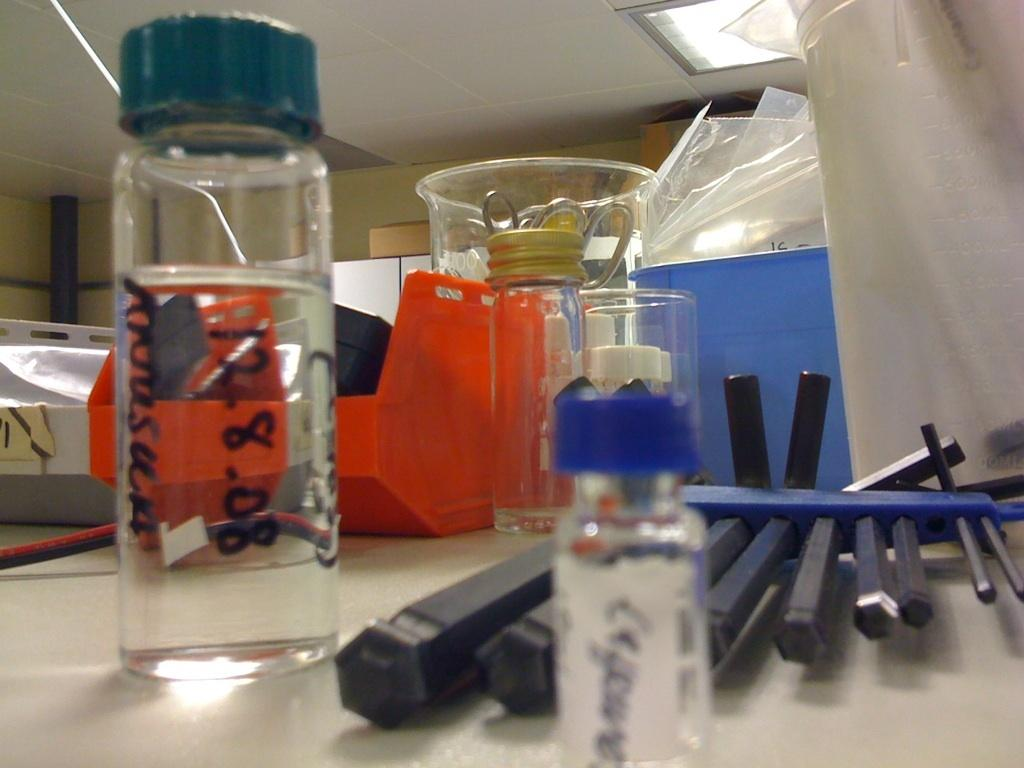What type of container is visible in the image? There is a bottle and a jar in the image. What other objects can be seen in the image? There are scissors, covers, and tubes in the image. Where are these objects placed? The objects are placed on a table. What part of the room can be seen in the image? The ceiling is visible in the image. Is the grandfather sitting next to the mailbox in the image? There is no mailbox or grandfather present in the image. What color is the balloon floating above the tubes in the image? There is no balloon present in the image. 